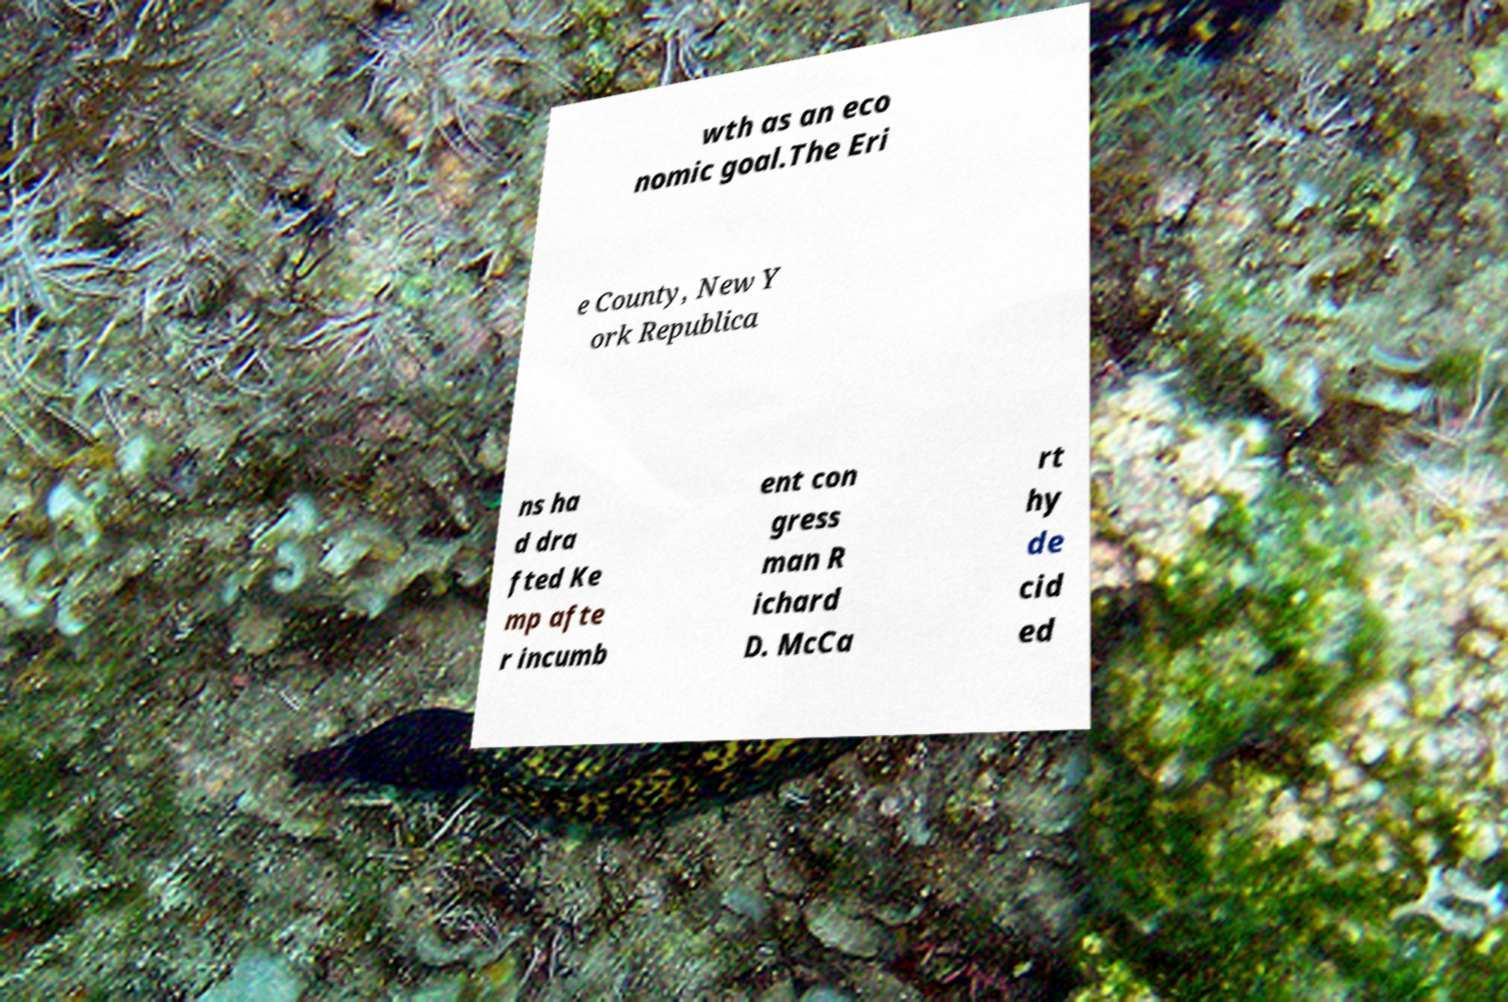I need the written content from this picture converted into text. Can you do that? wth as an eco nomic goal.The Eri e County, New Y ork Republica ns ha d dra fted Ke mp afte r incumb ent con gress man R ichard D. McCa rt hy de cid ed 